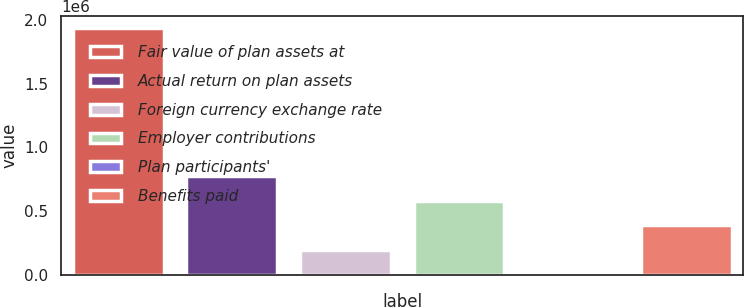Convert chart. <chart><loc_0><loc_0><loc_500><loc_500><bar_chart><fcel>Fair value of plan assets at<fcel>Actual return on plan assets<fcel>Foreign currency exchange rate<fcel>Employer contributions<fcel>Plan participants'<fcel>Benefits paid<nl><fcel>1.93306e+06<fcel>775351<fcel>196495<fcel>582399<fcel>3543<fcel>389447<nl></chart> 